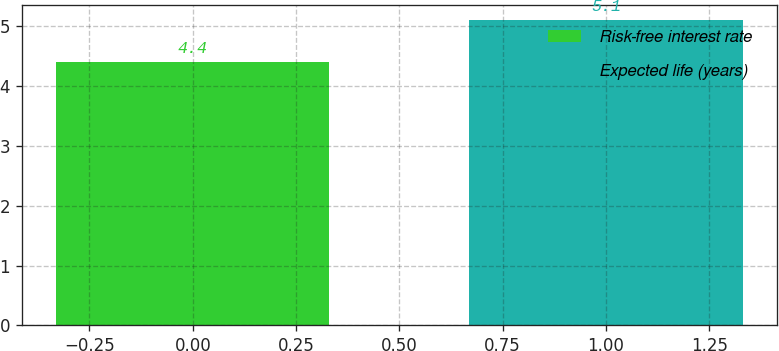Convert chart to OTSL. <chart><loc_0><loc_0><loc_500><loc_500><bar_chart><fcel>Risk-free interest rate<fcel>Expected life (years)<nl><fcel>4.4<fcel>5.1<nl></chart> 